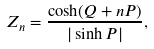Convert formula to latex. <formula><loc_0><loc_0><loc_500><loc_500>Z _ { n } = \frac { \cosh ( Q + n P ) } { | \sinh P | } ,</formula> 